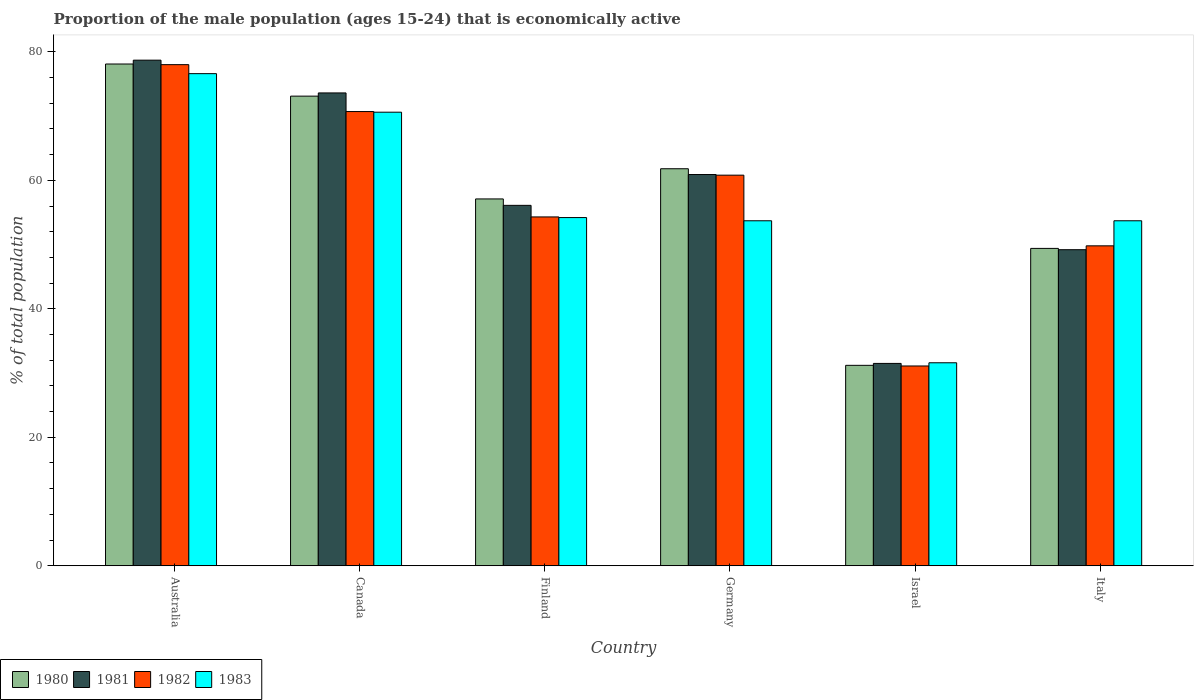Are the number of bars on each tick of the X-axis equal?
Provide a succinct answer. Yes. How many bars are there on the 1st tick from the left?
Your response must be concise. 4. How many bars are there on the 5th tick from the right?
Give a very brief answer. 4. What is the label of the 1st group of bars from the left?
Provide a succinct answer. Australia. What is the proportion of the male population that is economically active in 1982 in Israel?
Ensure brevity in your answer.  31.1. Across all countries, what is the maximum proportion of the male population that is economically active in 1981?
Ensure brevity in your answer.  78.7. Across all countries, what is the minimum proportion of the male population that is economically active in 1980?
Make the answer very short. 31.2. In which country was the proportion of the male population that is economically active in 1981 maximum?
Provide a succinct answer. Australia. What is the total proportion of the male population that is economically active in 1980 in the graph?
Offer a very short reply. 350.7. What is the difference between the proportion of the male population that is economically active in 1980 in Canada and that in Italy?
Your answer should be very brief. 23.7. What is the difference between the proportion of the male population that is economically active in 1980 in Italy and the proportion of the male population that is economically active in 1981 in Finland?
Offer a terse response. -6.7. What is the average proportion of the male population that is economically active in 1982 per country?
Your answer should be very brief. 57.45. What is the difference between the proportion of the male population that is economically active of/in 1983 and proportion of the male population that is economically active of/in 1980 in Israel?
Provide a succinct answer. 0.4. In how many countries, is the proportion of the male population that is economically active in 1983 greater than 60 %?
Make the answer very short. 2. What is the ratio of the proportion of the male population that is economically active in 1980 in Canada to that in Israel?
Offer a very short reply. 2.34. Is the difference between the proportion of the male population that is economically active in 1983 in Canada and Italy greater than the difference between the proportion of the male population that is economically active in 1980 in Canada and Italy?
Provide a succinct answer. No. What is the difference between the highest and the second highest proportion of the male population that is economically active in 1982?
Give a very brief answer. 9.9. What is the difference between the highest and the lowest proportion of the male population that is economically active in 1980?
Ensure brevity in your answer.  46.9. How many bars are there?
Your answer should be very brief. 24. Are all the bars in the graph horizontal?
Offer a terse response. No. Are the values on the major ticks of Y-axis written in scientific E-notation?
Ensure brevity in your answer.  No. Does the graph contain any zero values?
Give a very brief answer. No. Does the graph contain grids?
Provide a succinct answer. No. Where does the legend appear in the graph?
Provide a short and direct response. Bottom left. What is the title of the graph?
Provide a short and direct response. Proportion of the male population (ages 15-24) that is economically active. Does "1973" appear as one of the legend labels in the graph?
Provide a short and direct response. No. What is the label or title of the X-axis?
Provide a succinct answer. Country. What is the label or title of the Y-axis?
Make the answer very short. % of total population. What is the % of total population in 1980 in Australia?
Ensure brevity in your answer.  78.1. What is the % of total population of 1981 in Australia?
Provide a succinct answer. 78.7. What is the % of total population in 1983 in Australia?
Make the answer very short. 76.6. What is the % of total population of 1980 in Canada?
Give a very brief answer. 73.1. What is the % of total population of 1981 in Canada?
Give a very brief answer. 73.6. What is the % of total population in 1982 in Canada?
Provide a succinct answer. 70.7. What is the % of total population of 1983 in Canada?
Your answer should be very brief. 70.6. What is the % of total population of 1980 in Finland?
Keep it short and to the point. 57.1. What is the % of total population of 1981 in Finland?
Your answer should be very brief. 56.1. What is the % of total population of 1982 in Finland?
Keep it short and to the point. 54.3. What is the % of total population in 1983 in Finland?
Provide a short and direct response. 54.2. What is the % of total population of 1980 in Germany?
Keep it short and to the point. 61.8. What is the % of total population of 1981 in Germany?
Keep it short and to the point. 60.9. What is the % of total population of 1982 in Germany?
Make the answer very short. 60.8. What is the % of total population of 1983 in Germany?
Ensure brevity in your answer.  53.7. What is the % of total population of 1980 in Israel?
Offer a very short reply. 31.2. What is the % of total population of 1981 in Israel?
Make the answer very short. 31.5. What is the % of total population of 1982 in Israel?
Offer a very short reply. 31.1. What is the % of total population of 1983 in Israel?
Ensure brevity in your answer.  31.6. What is the % of total population in 1980 in Italy?
Provide a succinct answer. 49.4. What is the % of total population of 1981 in Italy?
Provide a succinct answer. 49.2. What is the % of total population of 1982 in Italy?
Your answer should be very brief. 49.8. What is the % of total population of 1983 in Italy?
Offer a very short reply. 53.7. Across all countries, what is the maximum % of total population in 1980?
Offer a very short reply. 78.1. Across all countries, what is the maximum % of total population in 1981?
Ensure brevity in your answer.  78.7. Across all countries, what is the maximum % of total population in 1982?
Ensure brevity in your answer.  78. Across all countries, what is the maximum % of total population in 1983?
Your response must be concise. 76.6. Across all countries, what is the minimum % of total population of 1980?
Your answer should be compact. 31.2. Across all countries, what is the minimum % of total population in 1981?
Give a very brief answer. 31.5. Across all countries, what is the minimum % of total population of 1982?
Provide a short and direct response. 31.1. Across all countries, what is the minimum % of total population in 1983?
Your response must be concise. 31.6. What is the total % of total population of 1980 in the graph?
Offer a very short reply. 350.7. What is the total % of total population in 1981 in the graph?
Make the answer very short. 350. What is the total % of total population of 1982 in the graph?
Your answer should be compact. 344.7. What is the total % of total population in 1983 in the graph?
Make the answer very short. 340.4. What is the difference between the % of total population in 1983 in Australia and that in Canada?
Provide a succinct answer. 6. What is the difference between the % of total population of 1981 in Australia and that in Finland?
Your answer should be compact. 22.6. What is the difference between the % of total population in 1982 in Australia and that in Finland?
Keep it short and to the point. 23.7. What is the difference between the % of total population of 1983 in Australia and that in Finland?
Offer a terse response. 22.4. What is the difference between the % of total population of 1980 in Australia and that in Germany?
Provide a succinct answer. 16.3. What is the difference between the % of total population of 1982 in Australia and that in Germany?
Your answer should be very brief. 17.2. What is the difference between the % of total population of 1983 in Australia and that in Germany?
Provide a short and direct response. 22.9. What is the difference between the % of total population in 1980 in Australia and that in Israel?
Your answer should be very brief. 46.9. What is the difference between the % of total population of 1981 in Australia and that in Israel?
Provide a short and direct response. 47.2. What is the difference between the % of total population of 1982 in Australia and that in Israel?
Keep it short and to the point. 46.9. What is the difference between the % of total population in 1983 in Australia and that in Israel?
Make the answer very short. 45. What is the difference between the % of total population in 1980 in Australia and that in Italy?
Offer a terse response. 28.7. What is the difference between the % of total population of 1981 in Australia and that in Italy?
Give a very brief answer. 29.5. What is the difference between the % of total population in 1982 in Australia and that in Italy?
Offer a very short reply. 28.2. What is the difference between the % of total population in 1983 in Australia and that in Italy?
Give a very brief answer. 22.9. What is the difference between the % of total population of 1981 in Canada and that in Finland?
Your answer should be very brief. 17.5. What is the difference between the % of total population in 1981 in Canada and that in Germany?
Your response must be concise. 12.7. What is the difference between the % of total population in 1982 in Canada and that in Germany?
Offer a terse response. 9.9. What is the difference between the % of total population in 1983 in Canada and that in Germany?
Provide a succinct answer. 16.9. What is the difference between the % of total population of 1980 in Canada and that in Israel?
Your answer should be very brief. 41.9. What is the difference between the % of total population of 1981 in Canada and that in Israel?
Keep it short and to the point. 42.1. What is the difference between the % of total population in 1982 in Canada and that in Israel?
Offer a very short reply. 39.6. What is the difference between the % of total population in 1980 in Canada and that in Italy?
Offer a terse response. 23.7. What is the difference between the % of total population of 1981 in Canada and that in Italy?
Your answer should be very brief. 24.4. What is the difference between the % of total population in 1982 in Canada and that in Italy?
Your answer should be compact. 20.9. What is the difference between the % of total population in 1980 in Finland and that in Germany?
Keep it short and to the point. -4.7. What is the difference between the % of total population in 1981 in Finland and that in Germany?
Make the answer very short. -4.8. What is the difference between the % of total population in 1982 in Finland and that in Germany?
Offer a very short reply. -6.5. What is the difference between the % of total population in 1980 in Finland and that in Israel?
Ensure brevity in your answer.  25.9. What is the difference between the % of total population in 1981 in Finland and that in Israel?
Your answer should be very brief. 24.6. What is the difference between the % of total population in 1982 in Finland and that in Israel?
Provide a succinct answer. 23.2. What is the difference between the % of total population of 1983 in Finland and that in Israel?
Provide a succinct answer. 22.6. What is the difference between the % of total population in 1981 in Finland and that in Italy?
Provide a short and direct response. 6.9. What is the difference between the % of total population in 1982 in Finland and that in Italy?
Offer a very short reply. 4.5. What is the difference between the % of total population of 1980 in Germany and that in Israel?
Provide a succinct answer. 30.6. What is the difference between the % of total population in 1981 in Germany and that in Israel?
Offer a terse response. 29.4. What is the difference between the % of total population in 1982 in Germany and that in Israel?
Provide a short and direct response. 29.7. What is the difference between the % of total population in 1983 in Germany and that in Israel?
Provide a succinct answer. 22.1. What is the difference between the % of total population in 1980 in Germany and that in Italy?
Your answer should be compact. 12.4. What is the difference between the % of total population in 1981 in Germany and that in Italy?
Your response must be concise. 11.7. What is the difference between the % of total population in 1983 in Germany and that in Italy?
Your answer should be compact. 0. What is the difference between the % of total population of 1980 in Israel and that in Italy?
Offer a very short reply. -18.2. What is the difference between the % of total population in 1981 in Israel and that in Italy?
Provide a short and direct response. -17.7. What is the difference between the % of total population in 1982 in Israel and that in Italy?
Your answer should be compact. -18.7. What is the difference between the % of total population in 1983 in Israel and that in Italy?
Give a very brief answer. -22.1. What is the difference between the % of total population of 1980 in Australia and the % of total population of 1983 in Canada?
Offer a terse response. 7.5. What is the difference between the % of total population of 1981 in Australia and the % of total population of 1983 in Canada?
Keep it short and to the point. 8.1. What is the difference between the % of total population in 1980 in Australia and the % of total population in 1982 in Finland?
Give a very brief answer. 23.8. What is the difference between the % of total population in 1980 in Australia and the % of total population in 1983 in Finland?
Your response must be concise. 23.9. What is the difference between the % of total population of 1981 in Australia and the % of total population of 1982 in Finland?
Provide a succinct answer. 24.4. What is the difference between the % of total population of 1981 in Australia and the % of total population of 1983 in Finland?
Your response must be concise. 24.5. What is the difference between the % of total population of 1982 in Australia and the % of total population of 1983 in Finland?
Give a very brief answer. 23.8. What is the difference between the % of total population of 1980 in Australia and the % of total population of 1983 in Germany?
Make the answer very short. 24.4. What is the difference between the % of total population of 1982 in Australia and the % of total population of 1983 in Germany?
Your answer should be compact. 24.3. What is the difference between the % of total population in 1980 in Australia and the % of total population in 1981 in Israel?
Offer a very short reply. 46.6. What is the difference between the % of total population of 1980 in Australia and the % of total population of 1983 in Israel?
Offer a terse response. 46.5. What is the difference between the % of total population of 1981 in Australia and the % of total population of 1982 in Israel?
Give a very brief answer. 47.6. What is the difference between the % of total population in 1981 in Australia and the % of total population in 1983 in Israel?
Offer a terse response. 47.1. What is the difference between the % of total population of 1982 in Australia and the % of total population of 1983 in Israel?
Your answer should be compact. 46.4. What is the difference between the % of total population of 1980 in Australia and the % of total population of 1981 in Italy?
Your answer should be compact. 28.9. What is the difference between the % of total population of 1980 in Australia and the % of total population of 1982 in Italy?
Provide a succinct answer. 28.3. What is the difference between the % of total population in 1980 in Australia and the % of total population in 1983 in Italy?
Give a very brief answer. 24.4. What is the difference between the % of total population of 1981 in Australia and the % of total population of 1982 in Italy?
Ensure brevity in your answer.  28.9. What is the difference between the % of total population of 1981 in Australia and the % of total population of 1983 in Italy?
Your answer should be very brief. 25. What is the difference between the % of total population in 1982 in Australia and the % of total population in 1983 in Italy?
Your response must be concise. 24.3. What is the difference between the % of total population of 1980 in Canada and the % of total population of 1982 in Finland?
Make the answer very short. 18.8. What is the difference between the % of total population of 1980 in Canada and the % of total population of 1983 in Finland?
Your answer should be compact. 18.9. What is the difference between the % of total population in 1981 in Canada and the % of total population in 1982 in Finland?
Your answer should be very brief. 19.3. What is the difference between the % of total population of 1982 in Canada and the % of total population of 1983 in Finland?
Your response must be concise. 16.5. What is the difference between the % of total population in 1980 in Canada and the % of total population in 1981 in Germany?
Provide a short and direct response. 12.2. What is the difference between the % of total population of 1982 in Canada and the % of total population of 1983 in Germany?
Offer a terse response. 17. What is the difference between the % of total population of 1980 in Canada and the % of total population of 1981 in Israel?
Keep it short and to the point. 41.6. What is the difference between the % of total population of 1980 in Canada and the % of total population of 1982 in Israel?
Make the answer very short. 42. What is the difference between the % of total population in 1980 in Canada and the % of total population in 1983 in Israel?
Offer a terse response. 41.5. What is the difference between the % of total population of 1981 in Canada and the % of total population of 1982 in Israel?
Offer a very short reply. 42.5. What is the difference between the % of total population of 1982 in Canada and the % of total population of 1983 in Israel?
Make the answer very short. 39.1. What is the difference between the % of total population in 1980 in Canada and the % of total population in 1981 in Italy?
Provide a short and direct response. 23.9. What is the difference between the % of total population of 1980 in Canada and the % of total population of 1982 in Italy?
Provide a succinct answer. 23.3. What is the difference between the % of total population of 1980 in Canada and the % of total population of 1983 in Italy?
Provide a short and direct response. 19.4. What is the difference between the % of total population in 1981 in Canada and the % of total population in 1982 in Italy?
Ensure brevity in your answer.  23.8. What is the difference between the % of total population of 1981 in Canada and the % of total population of 1983 in Italy?
Make the answer very short. 19.9. What is the difference between the % of total population of 1980 in Finland and the % of total population of 1982 in Germany?
Offer a terse response. -3.7. What is the difference between the % of total population in 1980 in Finland and the % of total population in 1983 in Germany?
Ensure brevity in your answer.  3.4. What is the difference between the % of total population in 1981 in Finland and the % of total population in 1982 in Germany?
Your answer should be very brief. -4.7. What is the difference between the % of total population in 1981 in Finland and the % of total population in 1983 in Germany?
Your response must be concise. 2.4. What is the difference between the % of total population of 1980 in Finland and the % of total population of 1981 in Israel?
Offer a very short reply. 25.6. What is the difference between the % of total population in 1980 in Finland and the % of total population in 1982 in Israel?
Provide a short and direct response. 26. What is the difference between the % of total population in 1980 in Finland and the % of total population in 1983 in Israel?
Make the answer very short. 25.5. What is the difference between the % of total population of 1981 in Finland and the % of total population of 1982 in Israel?
Give a very brief answer. 25. What is the difference between the % of total population of 1982 in Finland and the % of total population of 1983 in Israel?
Your answer should be compact. 22.7. What is the difference between the % of total population in 1980 in Finland and the % of total population in 1982 in Italy?
Ensure brevity in your answer.  7.3. What is the difference between the % of total population in 1980 in Finland and the % of total population in 1983 in Italy?
Offer a terse response. 3.4. What is the difference between the % of total population of 1981 in Finland and the % of total population of 1982 in Italy?
Ensure brevity in your answer.  6.3. What is the difference between the % of total population of 1980 in Germany and the % of total population of 1981 in Israel?
Make the answer very short. 30.3. What is the difference between the % of total population of 1980 in Germany and the % of total population of 1982 in Israel?
Offer a very short reply. 30.7. What is the difference between the % of total population of 1980 in Germany and the % of total population of 1983 in Israel?
Provide a succinct answer. 30.2. What is the difference between the % of total population in 1981 in Germany and the % of total population in 1982 in Israel?
Keep it short and to the point. 29.8. What is the difference between the % of total population of 1981 in Germany and the % of total population of 1983 in Israel?
Offer a terse response. 29.3. What is the difference between the % of total population of 1982 in Germany and the % of total population of 1983 in Israel?
Give a very brief answer. 29.2. What is the difference between the % of total population of 1980 in Germany and the % of total population of 1982 in Italy?
Offer a very short reply. 12. What is the difference between the % of total population of 1980 in Germany and the % of total population of 1983 in Italy?
Your response must be concise. 8.1. What is the difference between the % of total population of 1981 in Germany and the % of total population of 1983 in Italy?
Give a very brief answer. 7.2. What is the difference between the % of total population of 1982 in Germany and the % of total population of 1983 in Italy?
Provide a succinct answer. 7.1. What is the difference between the % of total population in 1980 in Israel and the % of total population in 1981 in Italy?
Offer a terse response. -18. What is the difference between the % of total population of 1980 in Israel and the % of total population of 1982 in Italy?
Keep it short and to the point. -18.6. What is the difference between the % of total population in 1980 in Israel and the % of total population in 1983 in Italy?
Offer a terse response. -22.5. What is the difference between the % of total population of 1981 in Israel and the % of total population of 1982 in Italy?
Your response must be concise. -18.3. What is the difference between the % of total population in 1981 in Israel and the % of total population in 1983 in Italy?
Your answer should be compact. -22.2. What is the difference between the % of total population in 1982 in Israel and the % of total population in 1983 in Italy?
Offer a very short reply. -22.6. What is the average % of total population of 1980 per country?
Provide a succinct answer. 58.45. What is the average % of total population of 1981 per country?
Your response must be concise. 58.33. What is the average % of total population in 1982 per country?
Provide a short and direct response. 57.45. What is the average % of total population of 1983 per country?
Make the answer very short. 56.73. What is the difference between the % of total population of 1980 and % of total population of 1981 in Australia?
Offer a very short reply. -0.6. What is the difference between the % of total population in 1980 and % of total population in 1982 in Australia?
Your answer should be compact. 0.1. What is the difference between the % of total population in 1981 and % of total population in 1982 in Australia?
Your answer should be compact. 0.7. What is the difference between the % of total population of 1980 and % of total population of 1981 in Canada?
Ensure brevity in your answer.  -0.5. What is the difference between the % of total population in 1980 and % of total population in 1982 in Finland?
Give a very brief answer. 2.8. What is the difference between the % of total population of 1981 and % of total population of 1982 in Finland?
Your answer should be compact. 1.8. What is the difference between the % of total population in 1980 and % of total population in 1981 in Germany?
Your response must be concise. 0.9. What is the difference between the % of total population of 1980 and % of total population of 1982 in Germany?
Your answer should be very brief. 1. What is the difference between the % of total population of 1981 and % of total population of 1982 in Germany?
Provide a short and direct response. 0.1. What is the difference between the % of total population of 1982 and % of total population of 1983 in Germany?
Keep it short and to the point. 7.1. What is the difference between the % of total population of 1981 and % of total population of 1982 in Israel?
Provide a short and direct response. 0.4. What is the difference between the % of total population in 1981 and % of total population in 1983 in Israel?
Your answer should be very brief. -0.1. What is the difference between the % of total population of 1982 and % of total population of 1983 in Israel?
Ensure brevity in your answer.  -0.5. What is the difference between the % of total population in 1980 and % of total population in 1981 in Italy?
Your response must be concise. 0.2. What is the difference between the % of total population of 1980 and % of total population of 1982 in Italy?
Your response must be concise. -0.4. What is the difference between the % of total population in 1980 and % of total population in 1983 in Italy?
Your answer should be very brief. -4.3. What is the difference between the % of total population in 1981 and % of total population in 1982 in Italy?
Keep it short and to the point. -0.6. What is the difference between the % of total population in 1982 and % of total population in 1983 in Italy?
Offer a terse response. -3.9. What is the ratio of the % of total population of 1980 in Australia to that in Canada?
Provide a succinct answer. 1.07. What is the ratio of the % of total population of 1981 in Australia to that in Canada?
Your answer should be compact. 1.07. What is the ratio of the % of total population in 1982 in Australia to that in Canada?
Keep it short and to the point. 1.1. What is the ratio of the % of total population of 1983 in Australia to that in Canada?
Keep it short and to the point. 1.08. What is the ratio of the % of total population of 1980 in Australia to that in Finland?
Your answer should be compact. 1.37. What is the ratio of the % of total population in 1981 in Australia to that in Finland?
Your response must be concise. 1.4. What is the ratio of the % of total population of 1982 in Australia to that in Finland?
Give a very brief answer. 1.44. What is the ratio of the % of total population of 1983 in Australia to that in Finland?
Make the answer very short. 1.41. What is the ratio of the % of total population of 1980 in Australia to that in Germany?
Keep it short and to the point. 1.26. What is the ratio of the % of total population of 1981 in Australia to that in Germany?
Your answer should be compact. 1.29. What is the ratio of the % of total population in 1982 in Australia to that in Germany?
Your answer should be compact. 1.28. What is the ratio of the % of total population in 1983 in Australia to that in Germany?
Ensure brevity in your answer.  1.43. What is the ratio of the % of total population in 1980 in Australia to that in Israel?
Offer a very short reply. 2.5. What is the ratio of the % of total population of 1981 in Australia to that in Israel?
Ensure brevity in your answer.  2.5. What is the ratio of the % of total population in 1982 in Australia to that in Israel?
Give a very brief answer. 2.51. What is the ratio of the % of total population of 1983 in Australia to that in Israel?
Your response must be concise. 2.42. What is the ratio of the % of total population of 1980 in Australia to that in Italy?
Your response must be concise. 1.58. What is the ratio of the % of total population of 1981 in Australia to that in Italy?
Keep it short and to the point. 1.6. What is the ratio of the % of total population of 1982 in Australia to that in Italy?
Your answer should be compact. 1.57. What is the ratio of the % of total population of 1983 in Australia to that in Italy?
Provide a short and direct response. 1.43. What is the ratio of the % of total population in 1980 in Canada to that in Finland?
Your answer should be very brief. 1.28. What is the ratio of the % of total population in 1981 in Canada to that in Finland?
Offer a very short reply. 1.31. What is the ratio of the % of total population of 1982 in Canada to that in Finland?
Ensure brevity in your answer.  1.3. What is the ratio of the % of total population of 1983 in Canada to that in Finland?
Your answer should be very brief. 1.3. What is the ratio of the % of total population in 1980 in Canada to that in Germany?
Your answer should be compact. 1.18. What is the ratio of the % of total population in 1981 in Canada to that in Germany?
Keep it short and to the point. 1.21. What is the ratio of the % of total population in 1982 in Canada to that in Germany?
Provide a short and direct response. 1.16. What is the ratio of the % of total population of 1983 in Canada to that in Germany?
Your answer should be very brief. 1.31. What is the ratio of the % of total population in 1980 in Canada to that in Israel?
Offer a terse response. 2.34. What is the ratio of the % of total population of 1981 in Canada to that in Israel?
Provide a short and direct response. 2.34. What is the ratio of the % of total population of 1982 in Canada to that in Israel?
Provide a succinct answer. 2.27. What is the ratio of the % of total population of 1983 in Canada to that in Israel?
Ensure brevity in your answer.  2.23. What is the ratio of the % of total population in 1980 in Canada to that in Italy?
Ensure brevity in your answer.  1.48. What is the ratio of the % of total population in 1981 in Canada to that in Italy?
Offer a terse response. 1.5. What is the ratio of the % of total population in 1982 in Canada to that in Italy?
Ensure brevity in your answer.  1.42. What is the ratio of the % of total population of 1983 in Canada to that in Italy?
Give a very brief answer. 1.31. What is the ratio of the % of total population in 1980 in Finland to that in Germany?
Keep it short and to the point. 0.92. What is the ratio of the % of total population in 1981 in Finland to that in Germany?
Offer a terse response. 0.92. What is the ratio of the % of total population of 1982 in Finland to that in Germany?
Make the answer very short. 0.89. What is the ratio of the % of total population in 1983 in Finland to that in Germany?
Your answer should be very brief. 1.01. What is the ratio of the % of total population of 1980 in Finland to that in Israel?
Your answer should be very brief. 1.83. What is the ratio of the % of total population of 1981 in Finland to that in Israel?
Your response must be concise. 1.78. What is the ratio of the % of total population in 1982 in Finland to that in Israel?
Your response must be concise. 1.75. What is the ratio of the % of total population of 1983 in Finland to that in Israel?
Give a very brief answer. 1.72. What is the ratio of the % of total population in 1980 in Finland to that in Italy?
Keep it short and to the point. 1.16. What is the ratio of the % of total population of 1981 in Finland to that in Italy?
Ensure brevity in your answer.  1.14. What is the ratio of the % of total population of 1982 in Finland to that in Italy?
Provide a short and direct response. 1.09. What is the ratio of the % of total population in 1983 in Finland to that in Italy?
Ensure brevity in your answer.  1.01. What is the ratio of the % of total population of 1980 in Germany to that in Israel?
Provide a short and direct response. 1.98. What is the ratio of the % of total population in 1981 in Germany to that in Israel?
Provide a short and direct response. 1.93. What is the ratio of the % of total population of 1982 in Germany to that in Israel?
Your answer should be compact. 1.96. What is the ratio of the % of total population of 1983 in Germany to that in Israel?
Provide a succinct answer. 1.7. What is the ratio of the % of total population of 1980 in Germany to that in Italy?
Ensure brevity in your answer.  1.25. What is the ratio of the % of total population of 1981 in Germany to that in Italy?
Keep it short and to the point. 1.24. What is the ratio of the % of total population of 1982 in Germany to that in Italy?
Your answer should be compact. 1.22. What is the ratio of the % of total population in 1980 in Israel to that in Italy?
Ensure brevity in your answer.  0.63. What is the ratio of the % of total population in 1981 in Israel to that in Italy?
Provide a succinct answer. 0.64. What is the ratio of the % of total population in 1982 in Israel to that in Italy?
Make the answer very short. 0.62. What is the ratio of the % of total population of 1983 in Israel to that in Italy?
Keep it short and to the point. 0.59. What is the difference between the highest and the second highest % of total population in 1982?
Your response must be concise. 7.3. What is the difference between the highest and the second highest % of total population of 1983?
Ensure brevity in your answer.  6. What is the difference between the highest and the lowest % of total population of 1980?
Provide a short and direct response. 46.9. What is the difference between the highest and the lowest % of total population in 1981?
Make the answer very short. 47.2. What is the difference between the highest and the lowest % of total population in 1982?
Give a very brief answer. 46.9. What is the difference between the highest and the lowest % of total population in 1983?
Ensure brevity in your answer.  45. 